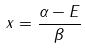<formula> <loc_0><loc_0><loc_500><loc_500>x = \frac { \alpha - E } { \beta }</formula> 